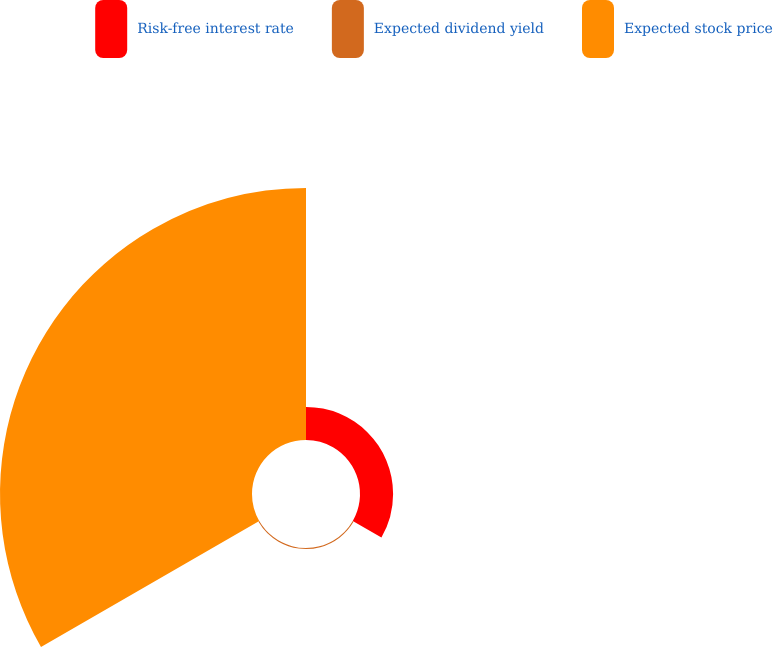Convert chart. <chart><loc_0><loc_0><loc_500><loc_500><pie_chart><fcel>Risk-free interest rate<fcel>Expected dividend yield<fcel>Expected stock price<nl><fcel>11.57%<fcel>0.35%<fcel>88.09%<nl></chart> 